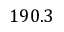Convert formula to latex. <formula><loc_0><loc_0><loc_500><loc_500>1 9 0 . 3</formula> 